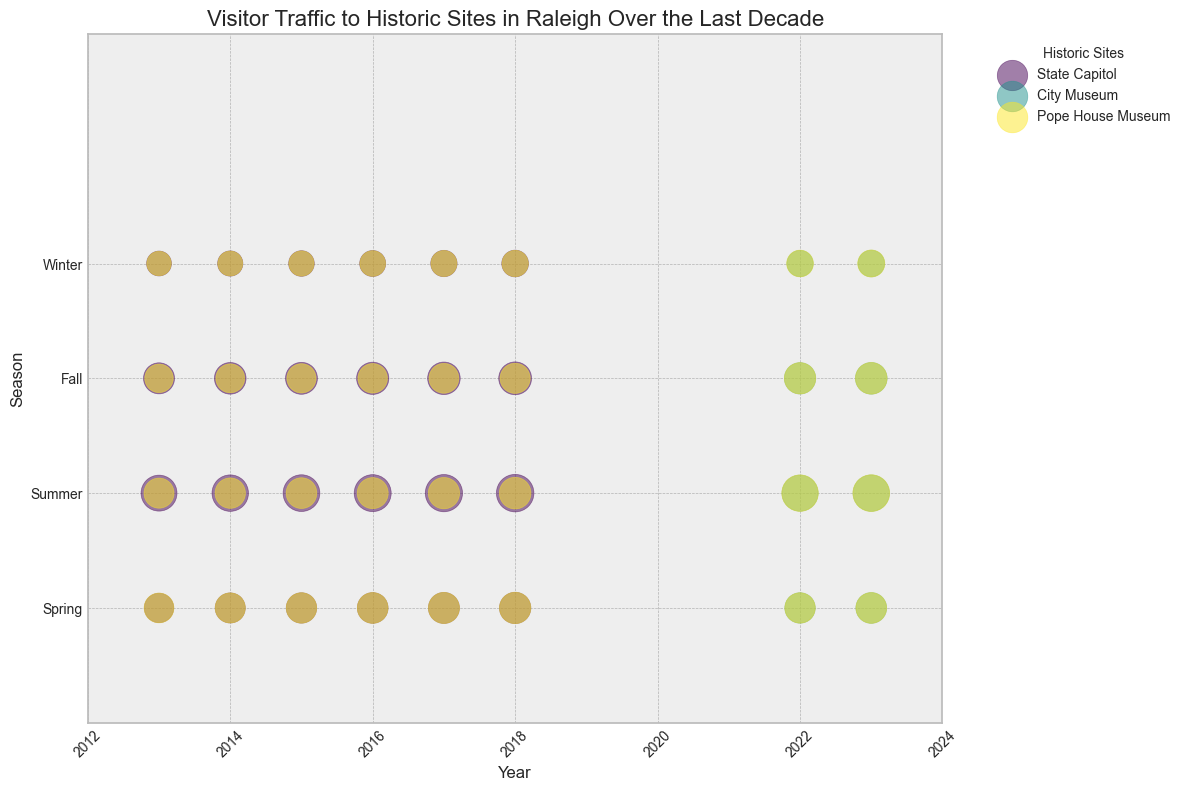What trend can you observe in visitor traffic to the State Capitol during the summer season from 2013 to 2018? The visitor traffic to the State Capitol during the summer season shows a consistent upward trend. Starting from 6700 visitors in 2013 and increasing each year to 7300 visitors in 2018. The bubbles representing summer seasons get larger each year on the plot.
Answer: Consistent upward trend How does the visitor count for the Pope House Museum in Winter of 2023 compare to the Winter of 2013? In Winter of 2013, the visitor count at the Pope House Museum was 3100. In Winter of 2023, it increased to 3800. Therefore, there’s an increase in visitor count.
Answer: Increased Which historic site has the highest visitor count in summer 2022? In summer 2022, the bubbles for each historic site can be compared in size. The largest bubble corresponds to the Pope House Museum, indicating it has the highest visitor count among the others.
Answer: Pope House Museum What is the average visitor count for the State Capitol during the Spring seasons from 2013 to 2018? To find the average, sum the visitor counts for Spring from 2013 to 2018: 4500 + 4700 + 4800 + 4900 + 5000 + 5100 = 29000. Then, divide by the number of years, which is 6. The calculation is 29000 / 6 = 4833.33
Answer: 4833.33 Compare the visitor trends during the Fall season between the State Capitol and the City Museum from 2022 to 2023. For the State Capitol, the trend is not applicable since data for Fall 2022 and 2023 is missing. For the City Museum, the Fall visitor counts are 5100 in 2022 and 5200 in 2023, indicating a slight increase.
Answer: City Museum, slight increase Is there any season where all three historic sites show the highest bubble size (visitor counts) in a single year? If so, which year and season? To find which season has the highest bubble size in a single year for all three sites, observe the consistent size increase and compare each season's years. The summer of 2023 shows all three historic sites having their highest visitor counts.
Answer: Summer 2023 Between 2013 and 2018, in which seasons did the City Museum record visitor counts? Since the City Museum data is only recorded from 2022 onwards, there are no visitor counts for the City Museum from 2013 to 2018. Referencing the bubble plot confirms this.
Answer: None 